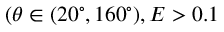<formula> <loc_0><loc_0><loc_500><loc_500>( \theta \in ( 2 0 ^ { \circ } , 1 6 0 ^ { \circ } ) , E > 0 . 1</formula> 